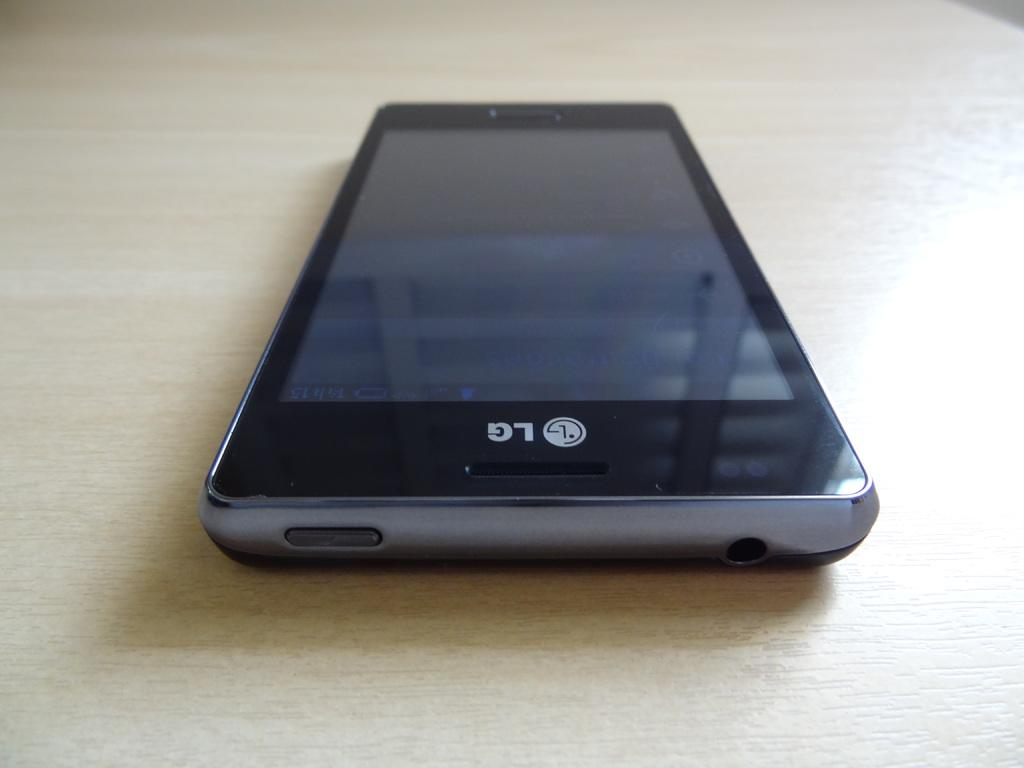<image>
Render a clear and concise summary of the photo. A LG chell phone placed on a light beige surface. 